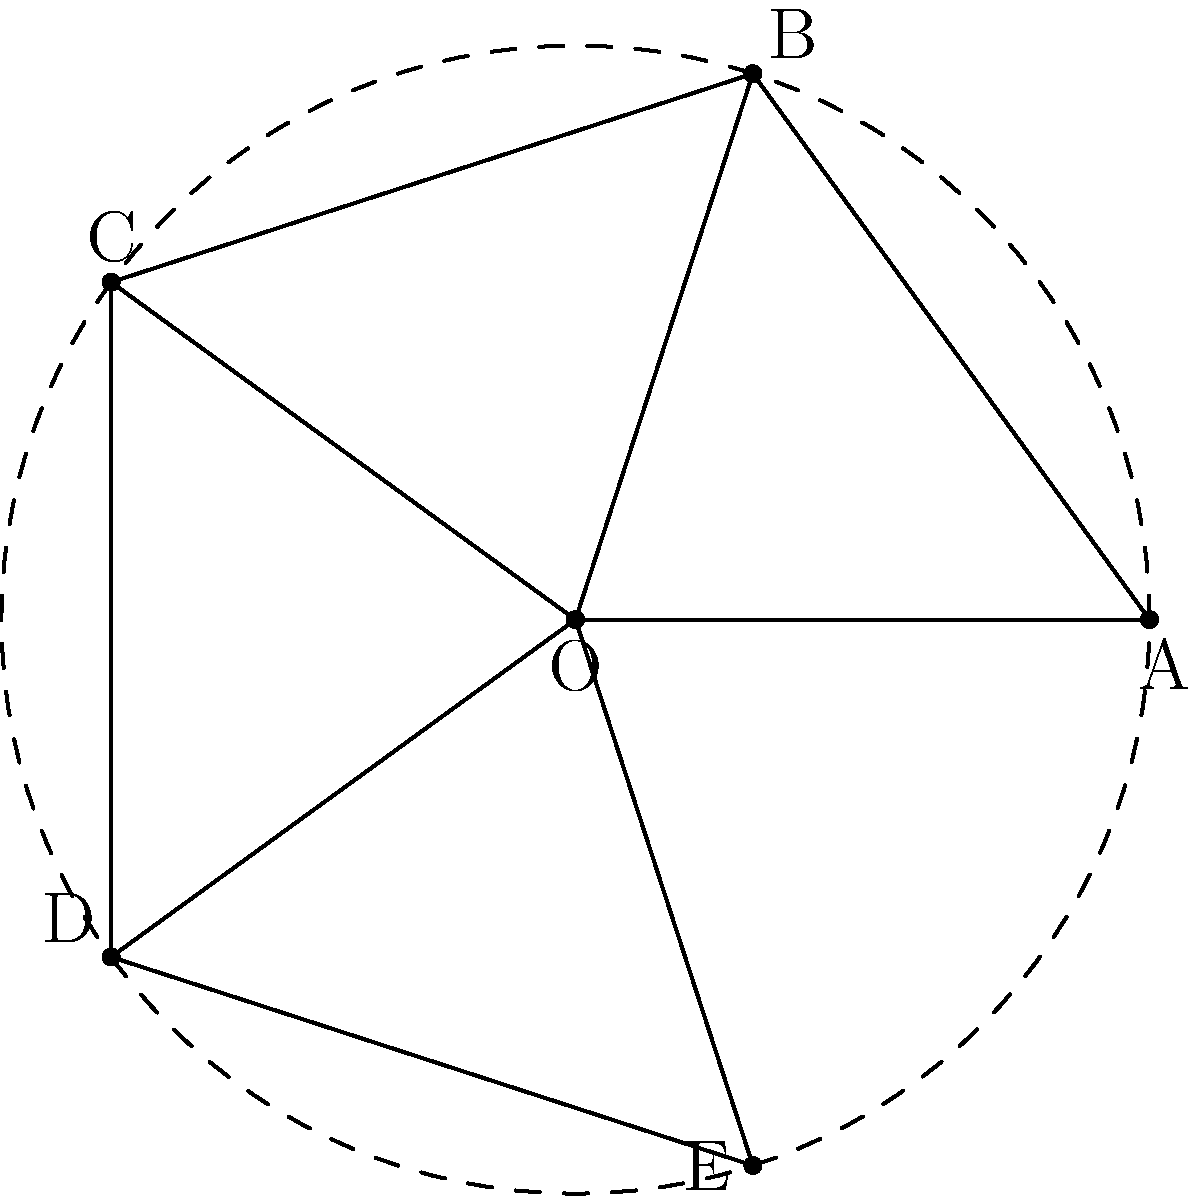For a cultural display, you want to create a star-shaped pattern using rotational symmetry. The pattern is formed by connecting the vertices of a regular pentagon to its center. If you rotate this star pattern by 144°, how many times will you need to repeat this rotation to return the star to its original position? Let's approach this step-by-step:

1) First, we need to understand the properties of a regular pentagon:
   - A regular pentagon has 5 sides and 5 vertices.
   - The internal angles of a regular pentagon are each 108°.

2) The star pattern is created by connecting each vertex to the center, dividing the pentagon into 5 equal sections.

3) The rotational symmetry of a regular pentagon (and thus, our star pattern) is 5-fold. This means the figure looks the same after every 1/5 of a full rotation.

4) A full rotation is 360°. To find the angle of each rotational symmetry, we divide 360° by 5:

   $$360° ÷ 5 = 72°$$

5) The question asks about a rotation of 144°. Let's see how this relates to our 72° symmetry:

   $$144° ÷ 72° = 2$$

   This means a 144° rotation is equivalent to two 72° rotations.

6) To return to the original position, we need to complete a full 360° rotation. Let's see how many 144° rotations this requires:

   $$360° ÷ 144° = 2.5$$

7) This means we need 2.5 rotations of 144° to complete a full 360° rotation and return to the original position.

8) However, we can only perform whole rotations. So we need to continue rotating until we reach a whole number of rotations that brings us back to the start.

9) The least common multiple of 2.5 and 1 is 5. This means after 5 rotations of 144°, we will return to the original position.
Answer: 5 rotations 